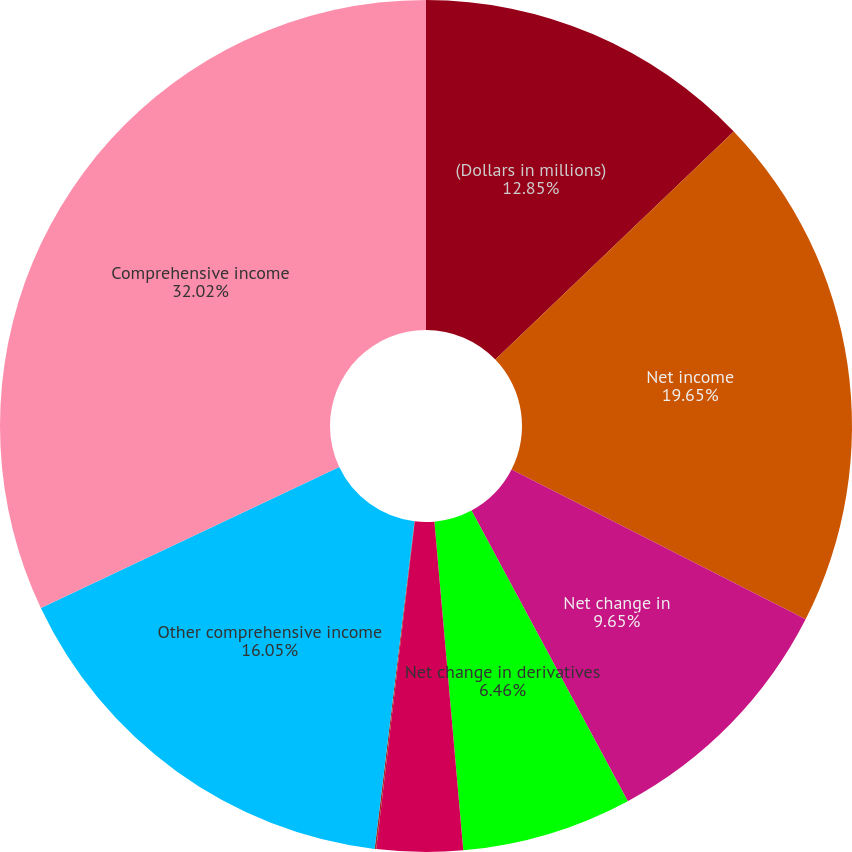Convert chart. <chart><loc_0><loc_0><loc_500><loc_500><pie_chart><fcel>(Dollars in millions)<fcel>Net income<fcel>Net change in<fcel>Net change in derivatives<fcel>Employee benefit plan<fcel>Net change in foreign currency<fcel>Other comprehensive income<fcel>Comprehensive income<nl><fcel>12.85%<fcel>19.65%<fcel>9.65%<fcel>6.46%<fcel>3.26%<fcel>0.06%<fcel>16.05%<fcel>32.03%<nl></chart> 